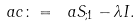<formula> <loc_0><loc_0><loc_500><loc_500>\ a c \colon = \ a S _ { ; 1 } - \lambda I .</formula> 